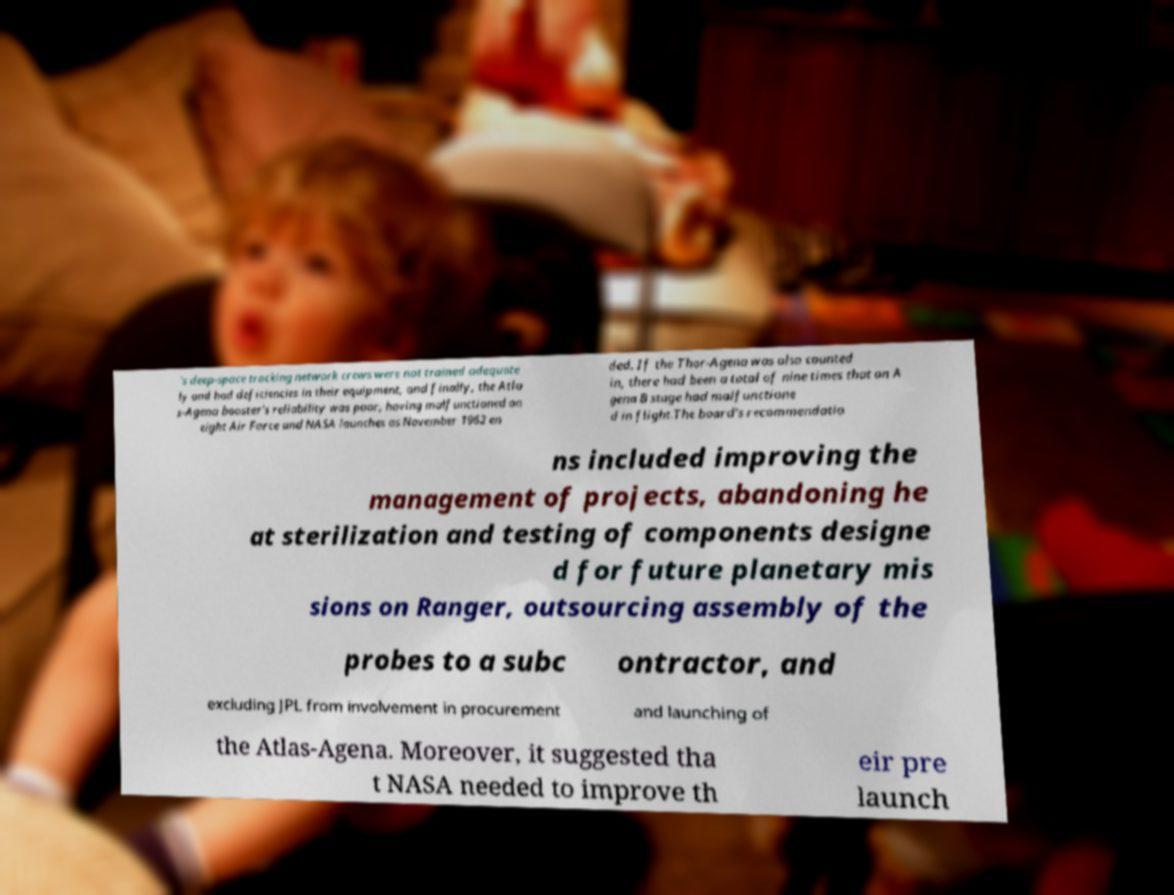Could you assist in decoding the text presented in this image and type it out clearly? 's deep-space tracking network crews were not trained adequate ly and had deficiencies in their equipment, and finally, the Atla s-Agena booster's reliability was poor, having malfunctioned on eight Air Force and NASA launches as November 1962 en ded. If the Thor-Agena was also counted in, there had been a total of nine times that an A gena B stage had malfunctione d in flight.The board's recommendatio ns included improving the management of projects, abandoning he at sterilization and testing of components designe d for future planetary mis sions on Ranger, outsourcing assembly of the probes to a subc ontractor, and excluding JPL from involvement in procurement and launching of the Atlas-Agena. Moreover, it suggested tha t NASA needed to improve th eir pre launch 